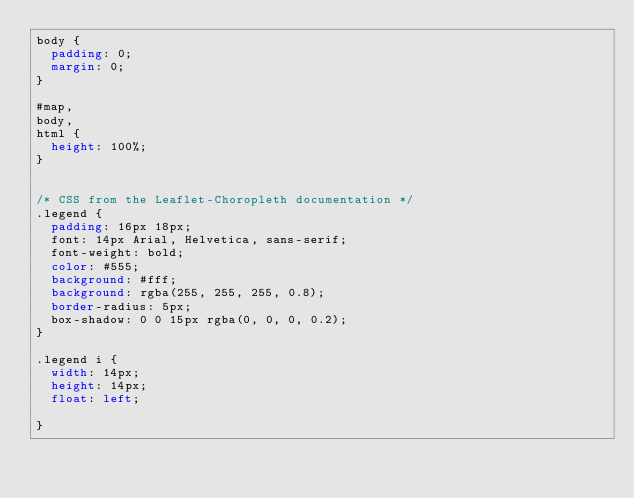Convert code to text. <code><loc_0><loc_0><loc_500><loc_500><_CSS_>body {
  padding: 0;
  margin: 0;
}

#map,
body,
html {
  height: 100%;
}


/* CSS from the Leaflet-Choropleth documentation */
.legend {
  padding: 16px 18px;
  font: 14px Arial, Helvetica, sans-serif;
  font-weight: bold;
  color: #555;
  background: #fff;
  background: rgba(255, 255, 255, 0.8);
  border-radius: 5px;
  box-shadow: 0 0 15px rgba(0, 0, 0, 0.2);
}

.legend i {
  width: 14px;
  height: 14px;
  float: left;

}</code> 